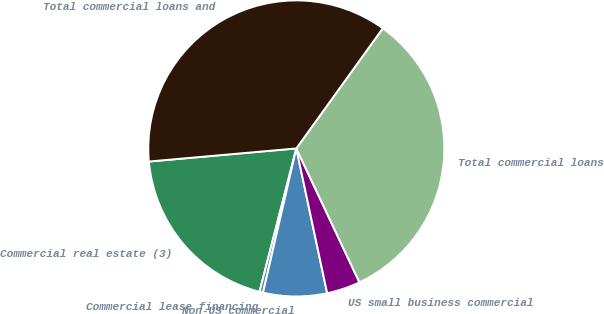Convert chart. <chart><loc_0><loc_0><loc_500><loc_500><pie_chart><fcel>Commercial real estate (3)<fcel>Commercial lease financing<fcel>Non-US commercial<fcel>US small business commercial<fcel>Total commercial loans<fcel>Total commercial loans and<nl><fcel>19.59%<fcel>0.39%<fcel>6.95%<fcel>3.67%<fcel>33.06%<fcel>36.34%<nl></chart> 